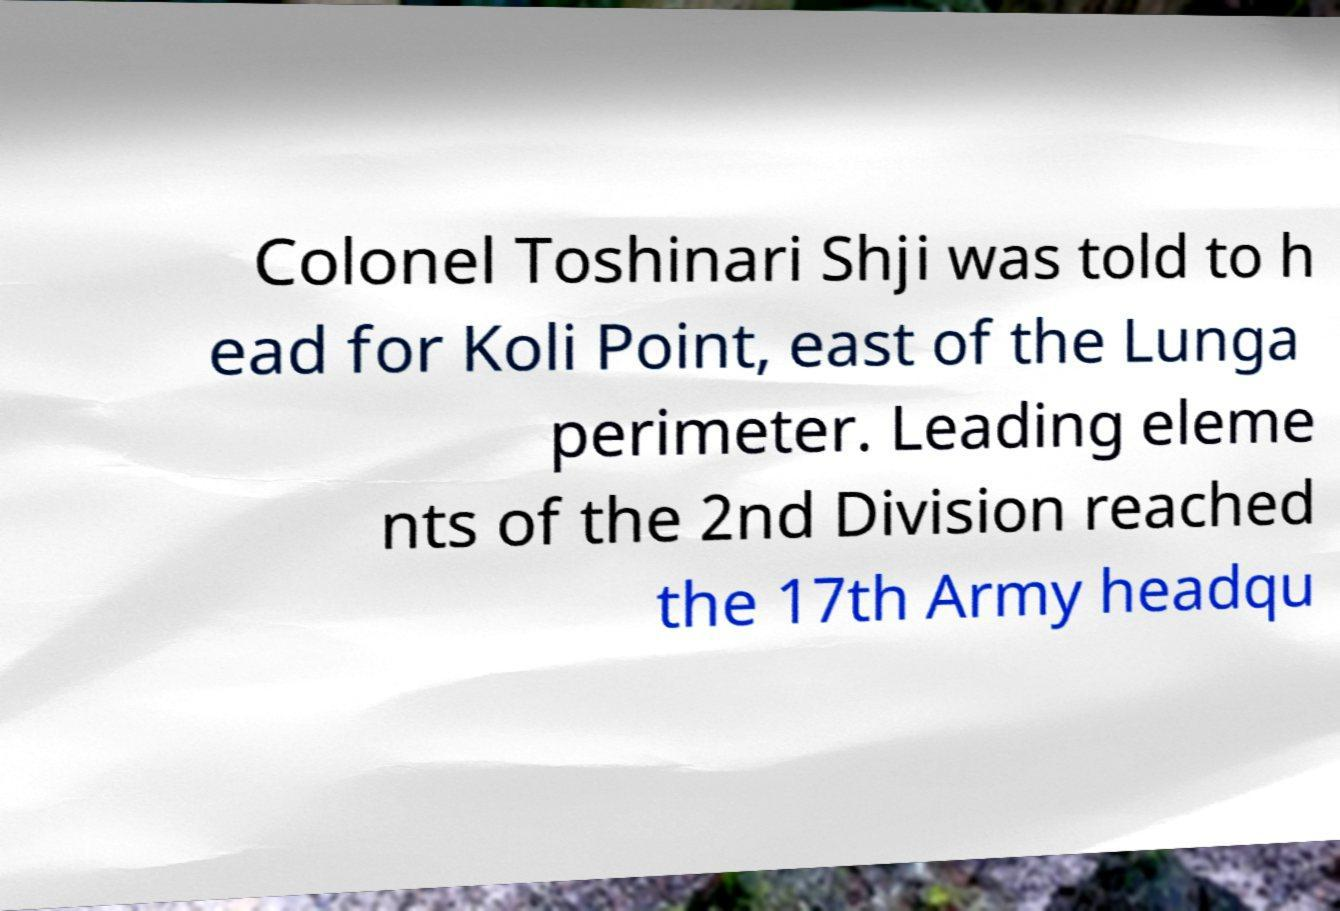Could you assist in decoding the text presented in this image and type it out clearly? Colonel Toshinari Shji was told to h ead for Koli Point, east of the Lunga perimeter. Leading eleme nts of the 2nd Division reached the 17th Army headqu 